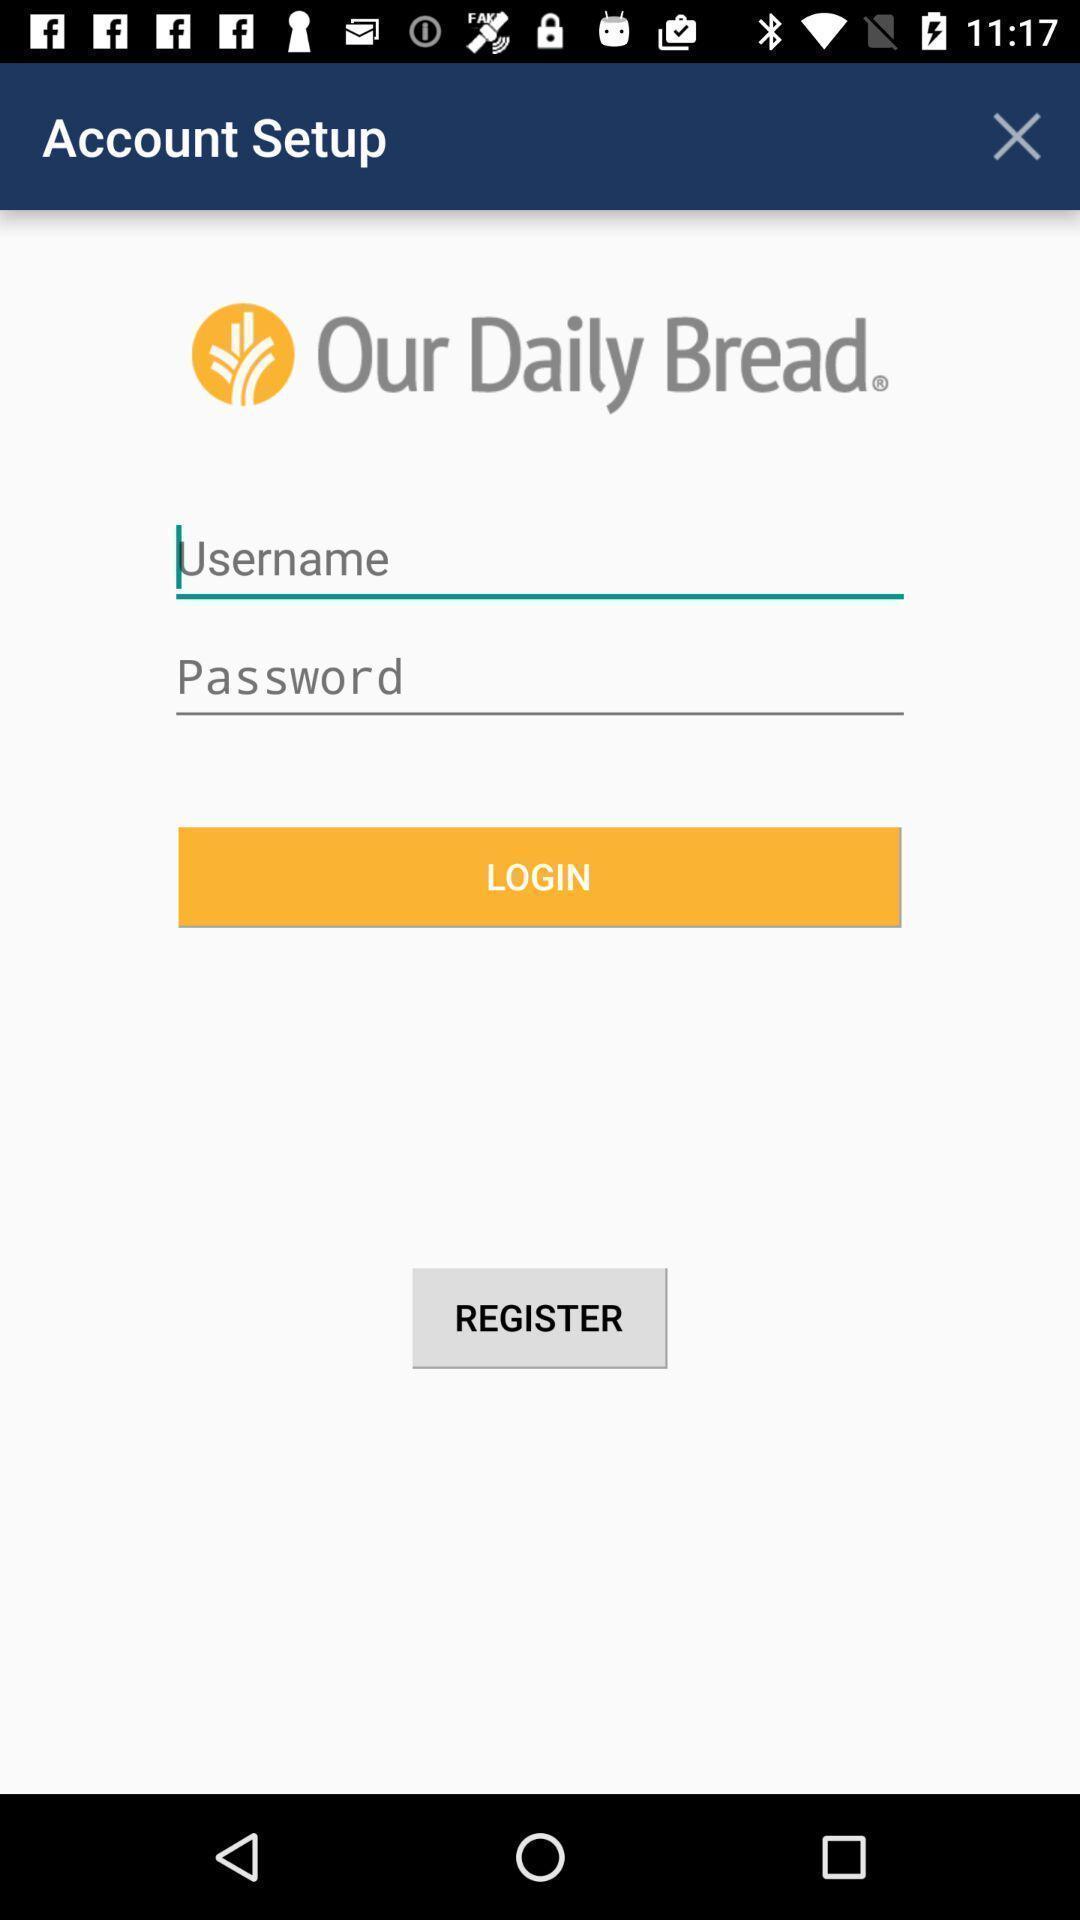Describe the content in this image. Login page. 